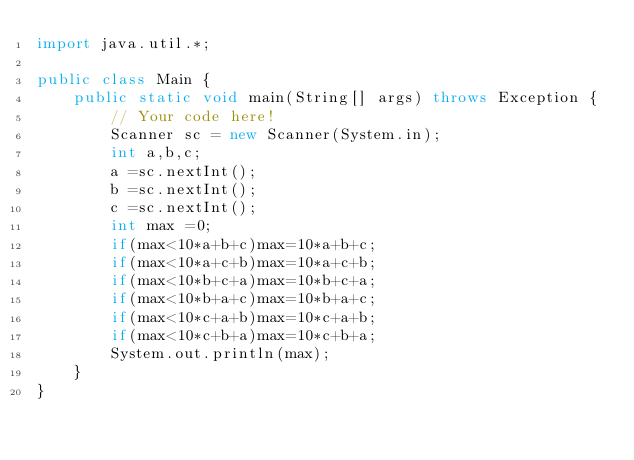Convert code to text. <code><loc_0><loc_0><loc_500><loc_500><_Java_>import java.util.*;

public class Main {
    public static void main(String[] args) throws Exception {
        // Your code here!
        Scanner sc = new Scanner(System.in);
        int a,b,c;
        a =sc.nextInt();
        b =sc.nextInt();
        c =sc.nextInt();
        int max =0;
        if(max<10*a+b+c)max=10*a+b+c;
        if(max<10*a+c+b)max=10*a+c+b;
        if(max<10*b+c+a)max=10*b+c+a;
        if(max<10*b+a+c)max=10*b+a+c;
        if(max<10*c+a+b)max=10*c+a+b;
        if(max<10*c+b+a)max=10*c+b+a;
        System.out.println(max);
    }
}
</code> 